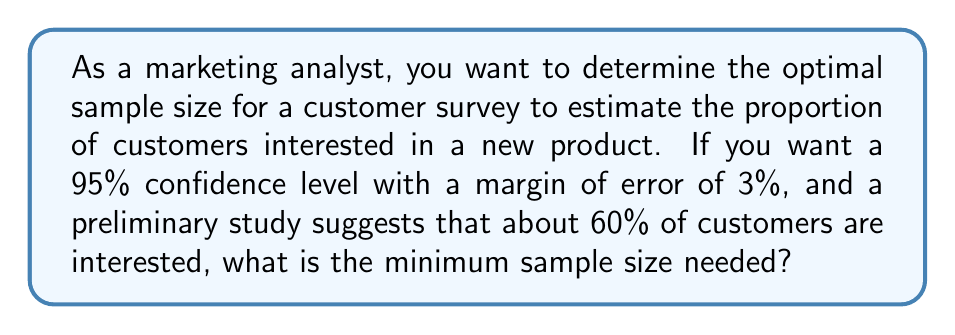Could you help me with this problem? To determine the optimal sample size for a customer survey using confidence intervals, we'll use the formula:

$$ n = \frac{z^2 \cdot p(1-p)}{E^2} $$

Where:
$n$ = sample size
$z$ = z-score (1.96 for 95% confidence level)
$p$ = estimated proportion (0.60 or 60%)
$E$ = margin of error (0.03 or 3%)

Steps:
1. Identify the values:
   $z = 1.96$ (95% confidence level)
   $p = 0.60$ (60% estimated proportion)
   $E = 0.03$ (3% margin of error)

2. Plug these values into the formula:
   $$ n = \frac{1.96^2 \cdot 0.60(1-0.60)}{0.03^2} $$

3. Calculate:
   $$ n = \frac{3.8416 \cdot 0.60 \cdot 0.40}{0.0009} $$
   $$ n = \frac{0.921984}{0.0009} $$
   $$ n = 1024.42667 $$

4. Round up to the nearest whole number:
   $n = 1025$

Therefore, the minimum sample size needed is 1025 customers.
Answer: 1025 customers 